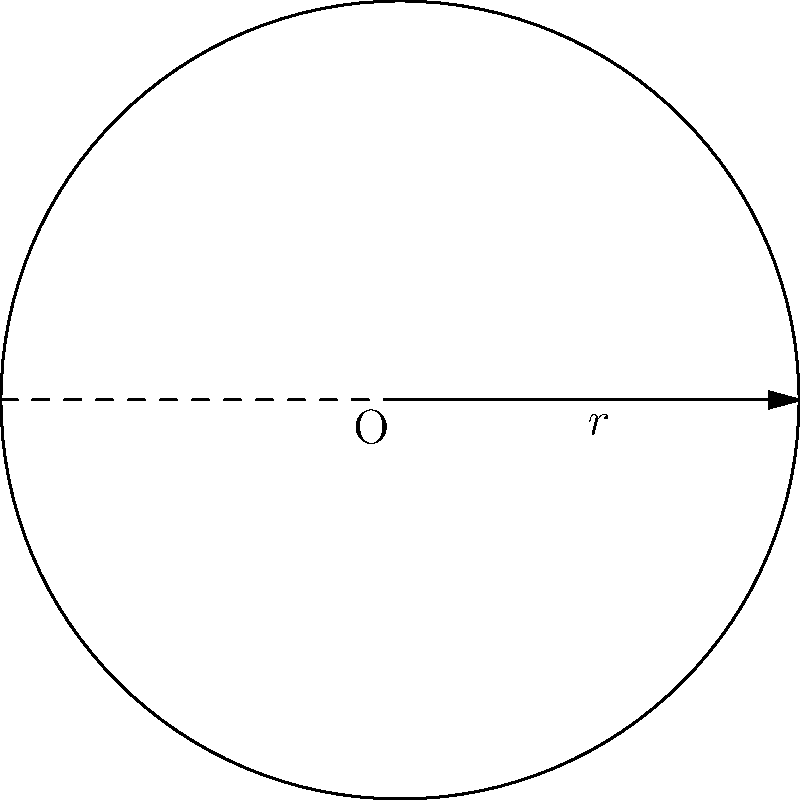A circular irrigation system covers a field with a radius of 30 meters. What is the circumference of the area covered by this system, and how many meters of piping would be needed to create a perimeter spray system along the edge of the irrigated area? To solve this problem, we need to use the formula for the circumference of a circle:

$$C = 2\pi r$$

Where:
$C$ = circumference
$\pi$ = pi (approximately 3.14159)
$r$ = radius

Given:
$r = 30$ meters

Step 1: Substitute the values into the formula:
$$C = 2\pi(30)$$

Step 2: Calculate:
$$C = 2(3.14159)(30)$$
$$C = 188.4954 \text{ meters}$$

Step 3: Round to two decimal places:
$$C \approx 188.50 \text{ meters}$$

The circumference of the irrigated area is approximately 188.50 meters. This is also the length of piping needed for a perimeter spray system along the edge of the irrigated area.
Answer: 188.50 meters 